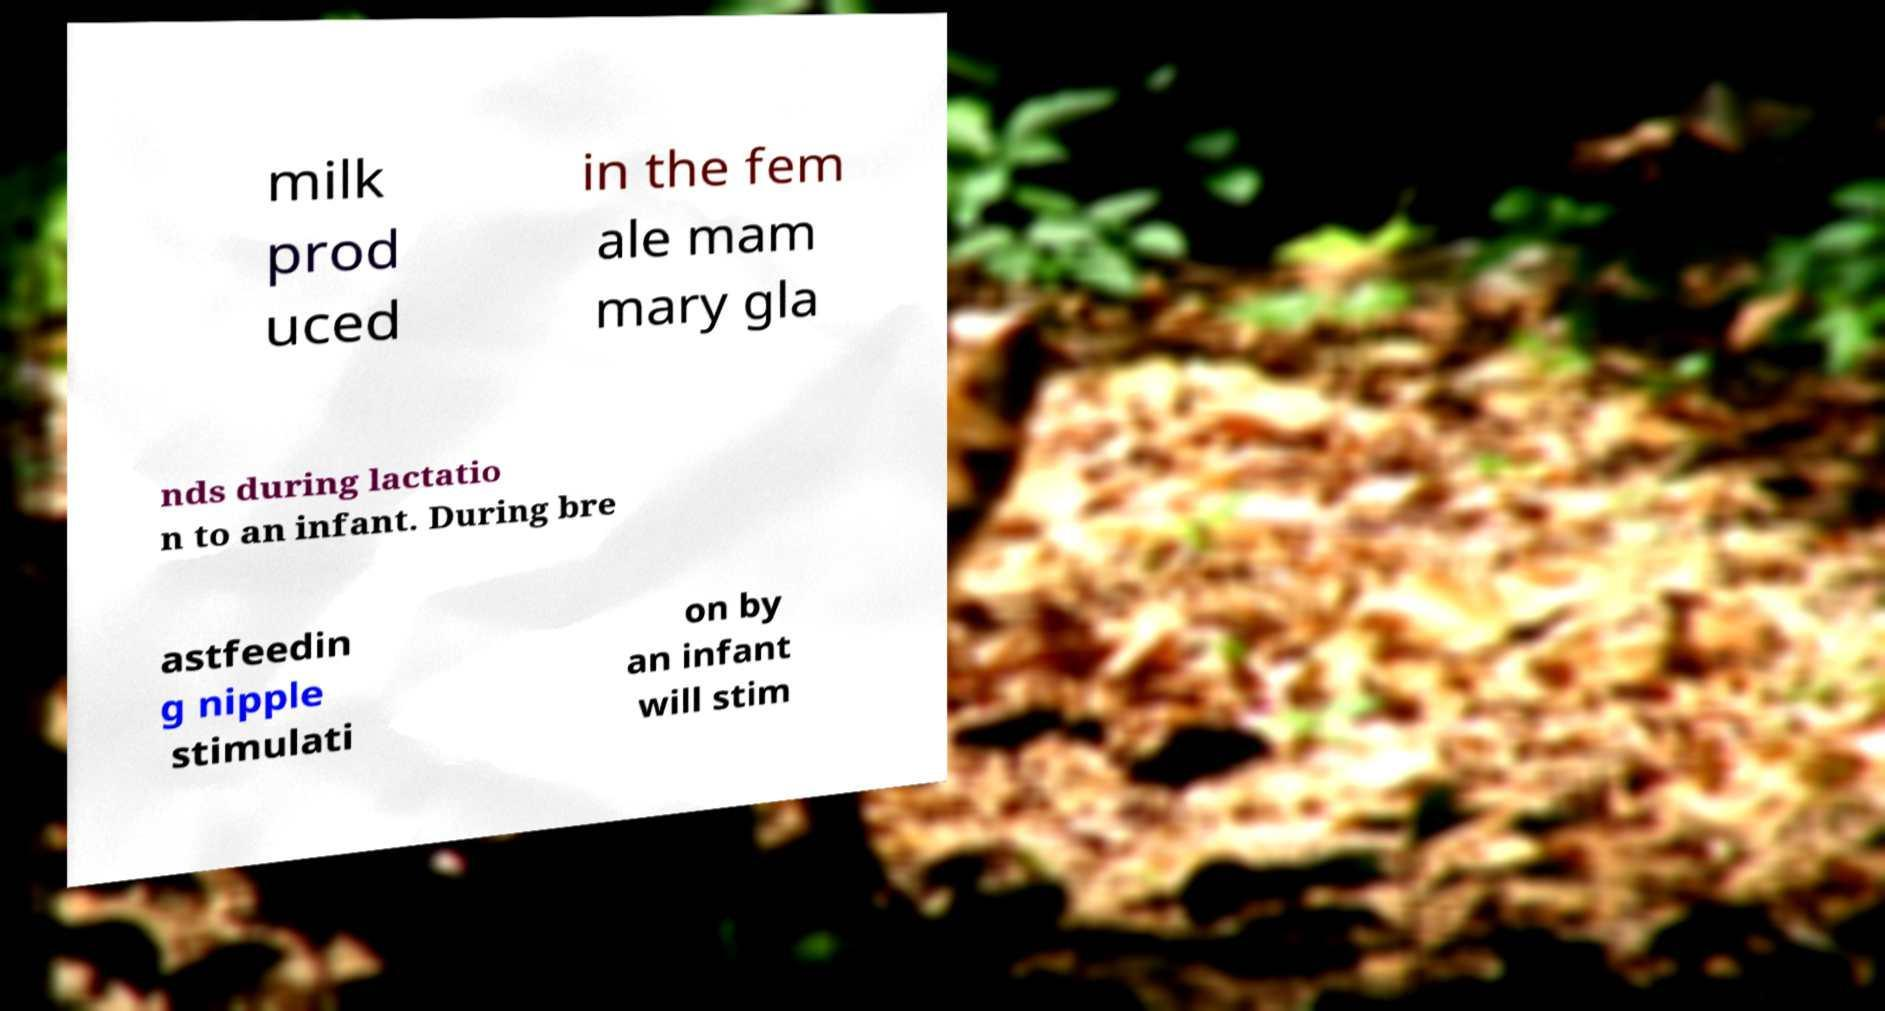What messages or text are displayed in this image? I need them in a readable, typed format. milk prod uced in the fem ale mam mary gla nds during lactatio n to an infant. During bre astfeedin g nipple stimulati on by an infant will stim 